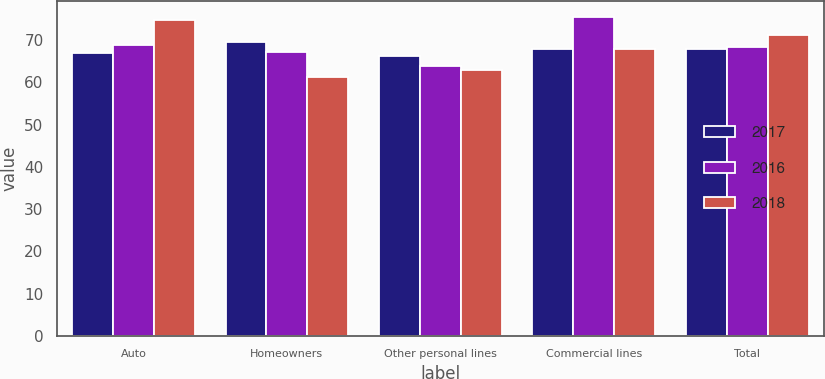<chart> <loc_0><loc_0><loc_500><loc_500><stacked_bar_chart><ecel><fcel>Auto<fcel>Homeowners<fcel>Other personal lines<fcel>Commercial lines<fcel>Total<nl><fcel>2017<fcel>67<fcel>69.5<fcel>66.2<fcel>68<fcel>68<nl><fcel>2016<fcel>68.9<fcel>67.2<fcel>64<fcel>75.5<fcel>68.3<nl><fcel>2018<fcel>74.7<fcel>61.3<fcel>62.9<fcel>68<fcel>71.2<nl></chart> 